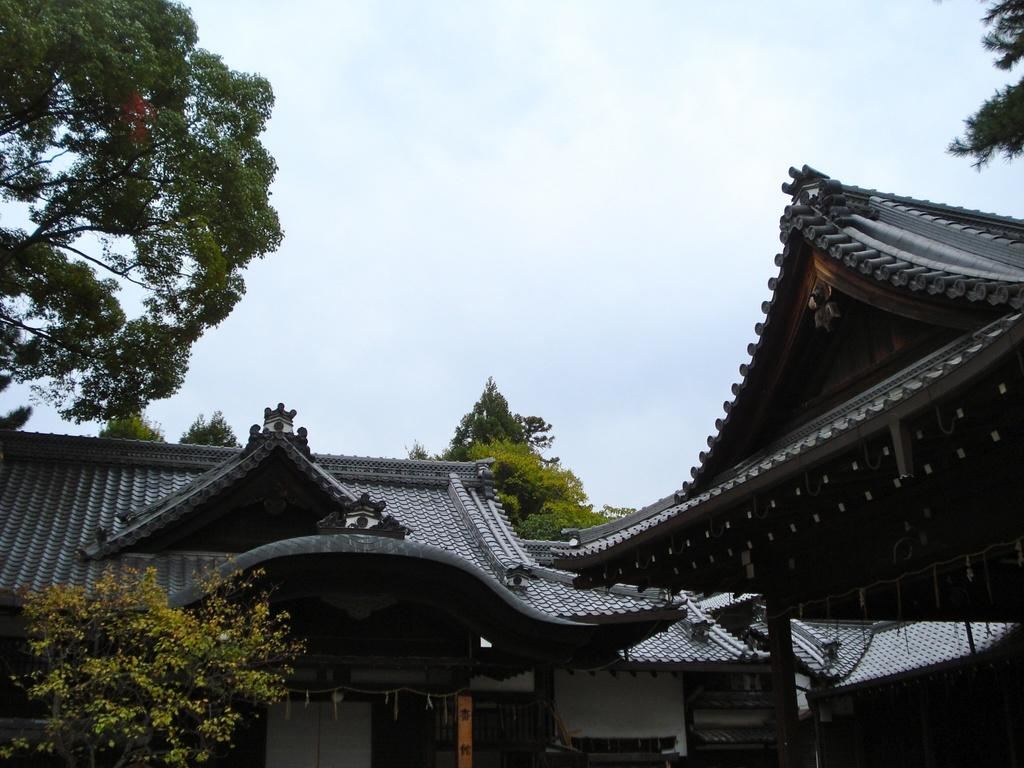What type of vegetation can be seen in the image? There are trees in the image. What structures are present in the image? There are buildings in the image. What is visible at the top of the image? The sky is visible at the top of the image. How many deer can be seen in the image? There are no deer present in the image. What is the rate of the buildings in the image? The rate of the buildings cannot be determined from the image, as buildings do not have rates. 